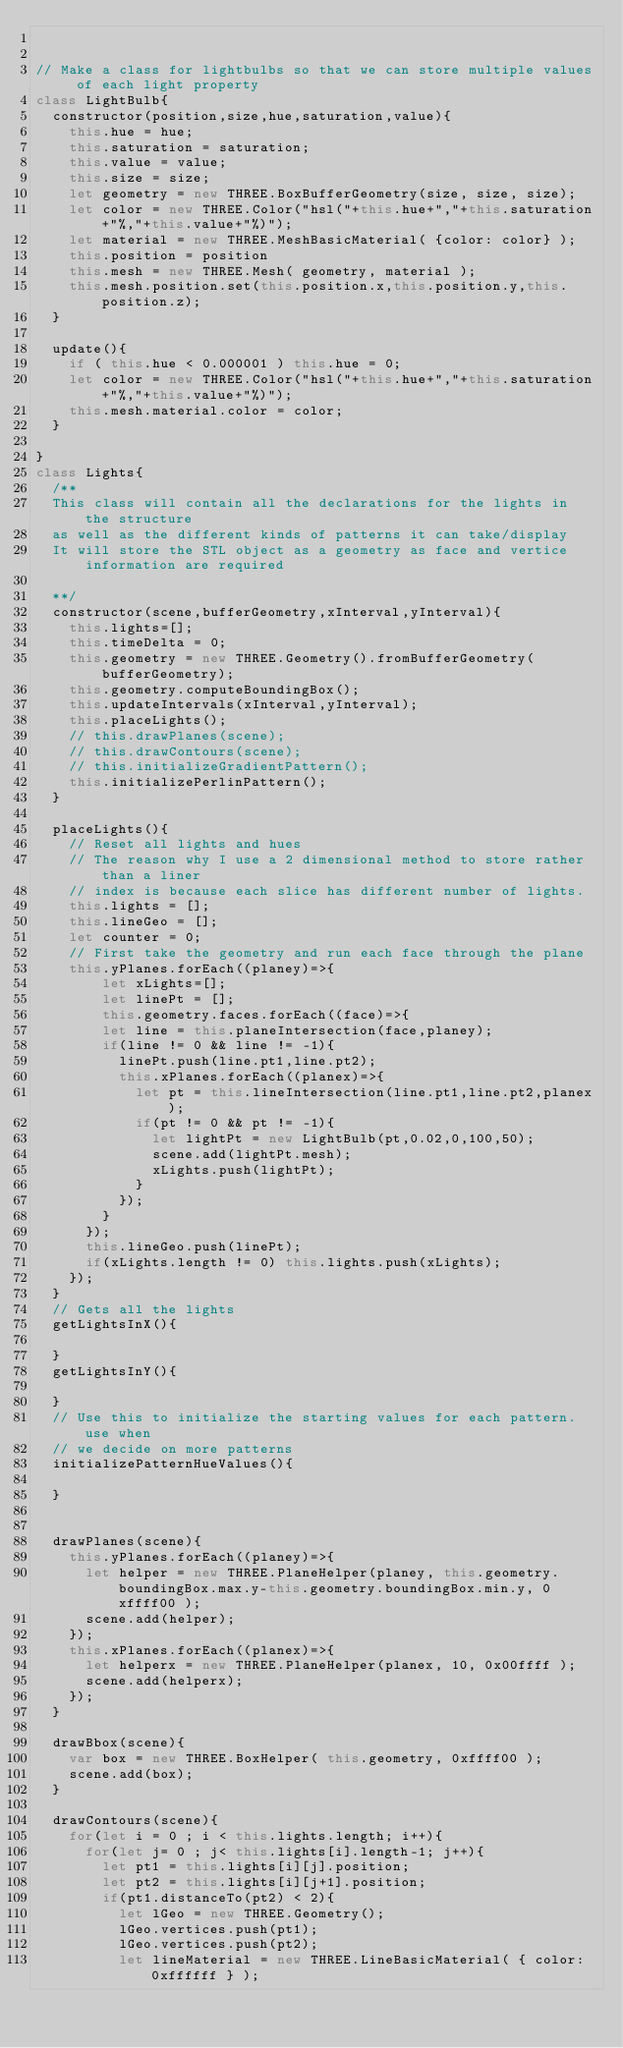<code> <loc_0><loc_0><loc_500><loc_500><_JavaScript_>

// Make a class for lightbulbs so that we can store multiple values of each light property
class LightBulb{
  constructor(position,size,hue,saturation,value){
    this.hue = hue;
    this.saturation = saturation;
    this.value = value;
    this.size = size;
    let geometry = new THREE.BoxBufferGeometry(size, size, size);
    let color = new THREE.Color("hsl("+this.hue+","+this.saturation+"%,"+this.value+"%)");
    let material = new THREE.MeshBasicMaterial( {color: color} );
    this.position = position
    this.mesh = new THREE.Mesh( geometry, material );
    this.mesh.position.set(this.position.x,this.position.y,this.position.z);
  }

  update(){
    if ( this.hue < 0.000001 ) this.hue = 0;
    let color = new THREE.Color("hsl("+this.hue+","+this.saturation+"%,"+this.value+"%)");
    this.mesh.material.color = color;
  }

}
class Lights{
  /**
  This class will contain all the declarations for the lights in the structure
  as well as the different kinds of patterns it can take/display
  It will store the STL object as a geometry as face and vertice information are required

  **/
  constructor(scene,bufferGeometry,xInterval,yInterval){
    this.lights=[];
    this.timeDelta = 0;
    this.geometry = new THREE.Geometry().fromBufferGeometry(bufferGeometry);
    this.geometry.computeBoundingBox();
    this.updateIntervals(xInterval,yInterval);
    this.placeLights();
    // this.drawPlanes(scene);
    // this.drawContours(scene);
    // this.initializeGradientPattern();
    this.initializePerlinPattern();
  }

  placeLights(){
    // Reset all lights and hues
    // The reason why I use a 2 dimensional method to store rather than a liner
    // index is because each slice has different number of lights.
    this.lights = [];
    this.lineGeo = [];
    let counter = 0;
    // First take the geometry and run each face through the plane
    this.yPlanes.forEach((planey)=>{
        let xLights=[];
        let linePt = [];
        this.geometry.faces.forEach((face)=>{
        let line = this.planeIntersection(face,planey);
        if(line != 0 && line != -1){
          linePt.push(line.pt1,line.pt2);
          this.xPlanes.forEach((planex)=>{
            let pt = this.lineIntersection(line.pt1,line.pt2,planex);
            if(pt != 0 && pt != -1){
              let lightPt = new LightBulb(pt,0.02,0,100,50);
              scene.add(lightPt.mesh);
              xLights.push(lightPt);
            }
          });
        }
      });
      this.lineGeo.push(linePt);
      if(xLights.length != 0) this.lights.push(xLights);
    });
  }
  // Gets all the lights
  getLightsInX(){

  }
  getLightsInY(){

  }
  // Use this to initialize the starting values for each pattern. use when
  // we decide on more patterns
  initializePatternHueValues(){

  }


  drawPlanes(scene){
    this.yPlanes.forEach((planey)=>{
      let helper = new THREE.PlaneHelper(planey, this.geometry.boundingBox.max.y-this.geometry.boundingBox.min.y, 0xffff00 );
      scene.add(helper);
    });
    this.xPlanes.forEach((planex)=>{
      let helperx = new THREE.PlaneHelper(planex, 10, 0x00ffff );
      scene.add(helperx);
    });
  }

  drawBbox(scene){
    var box = new THREE.BoxHelper( this.geometry, 0xffff00 );
    scene.add(box);
  }

  drawContours(scene){
    for(let i = 0 ; i < this.lights.length; i++){
      for(let j= 0 ; j< this.lights[i].length-1; j++){
        let pt1 = this.lights[i][j].position;
        let pt2 = this.lights[i][j+1].position;
        if(pt1.distanceTo(pt2) < 2){
          let lGeo = new THREE.Geometry();
          lGeo.vertices.push(pt1);
          lGeo.vertices.push(pt2);
          let lineMaterial = new THREE.LineBasicMaterial( { color: 0xffffff } );</code> 